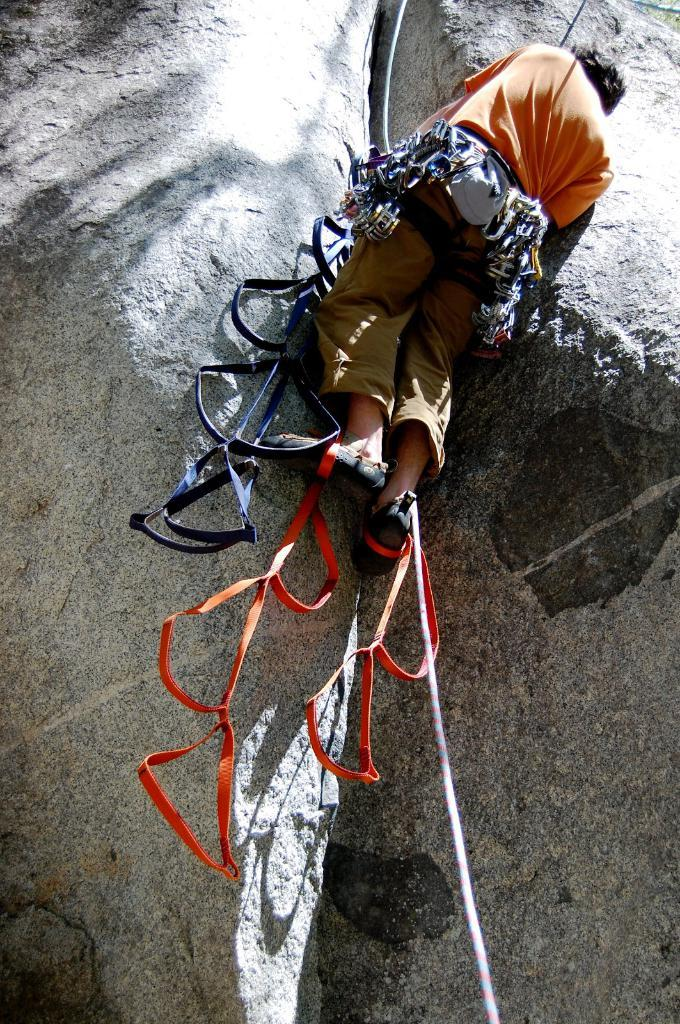Who is the person in the image? There is a man in the image. What is the man doing in the image? The man is climbing a huge rock. Is there any equipment being used by the man in the image? Yes, there is a rope tied around the man's waist. What type of wood is the man using to climb the rock in the image? There is no wood present in the image; the man is using a rope tied around his waist for assistance. 